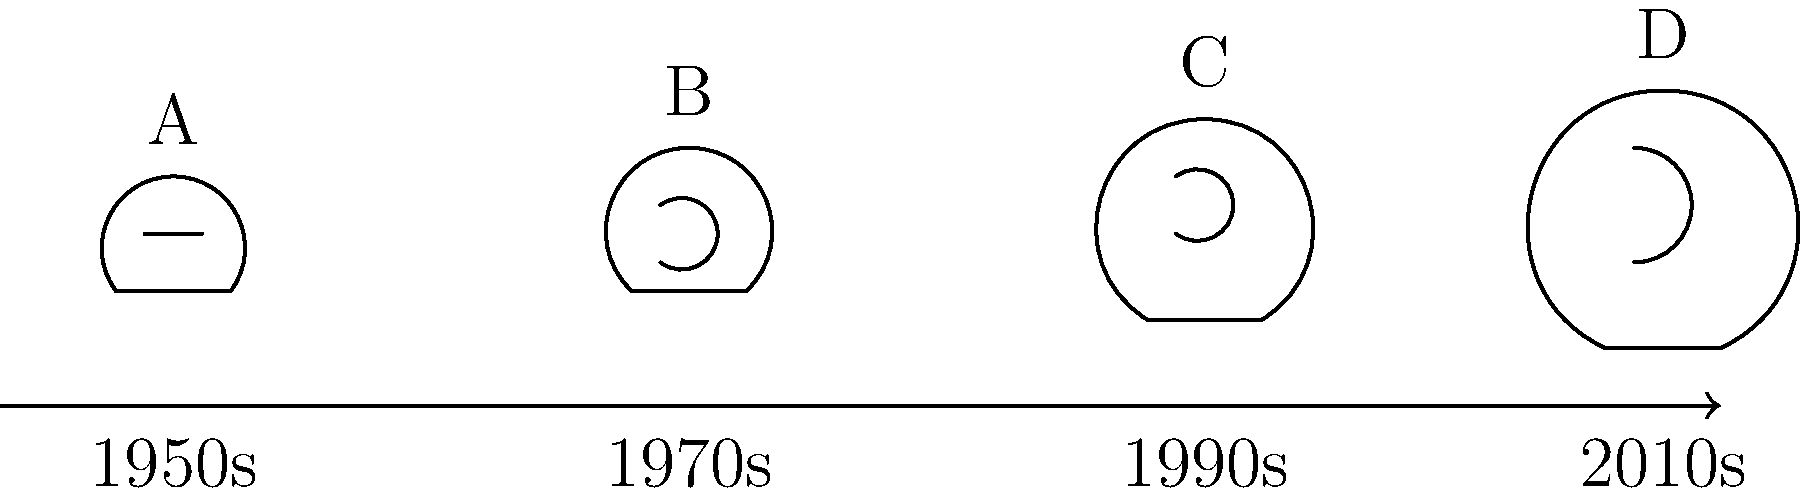Based on your experience as a football coach and your personal knowledge of Art Haege, which helmet design (A, B, C, or D) would most likely have been used during the period when Art Haege was actively coaching? To answer this question, we need to consider the following steps:

1. Recall that Art Haege was a football coach active in the 1960s and 1970s.

2. Analyze the helmet designs in the image:
   A (1950s): Simple leather helmet with a single bar face mask.
   B (1970s): More protective design with a curved face mask.
   C (1990s): Enhanced protection with a more complex face mask.
   D (2010s): Modern design with maximum protection and complex face mask.

3. Given Art Haege's active period, we should focus on designs from the 1960s and 1970s.

4. The helmet design closest to this period is B, representing the 1970s.

5. This design shows significant improvements in protection compared to the 1950s model, which aligns with the advancements in football equipment during Art Haege's coaching career.

Therefore, based on the timeline and Art Haege's active coaching period, helmet design B would most likely have been used during his coaching career.
Answer: B 